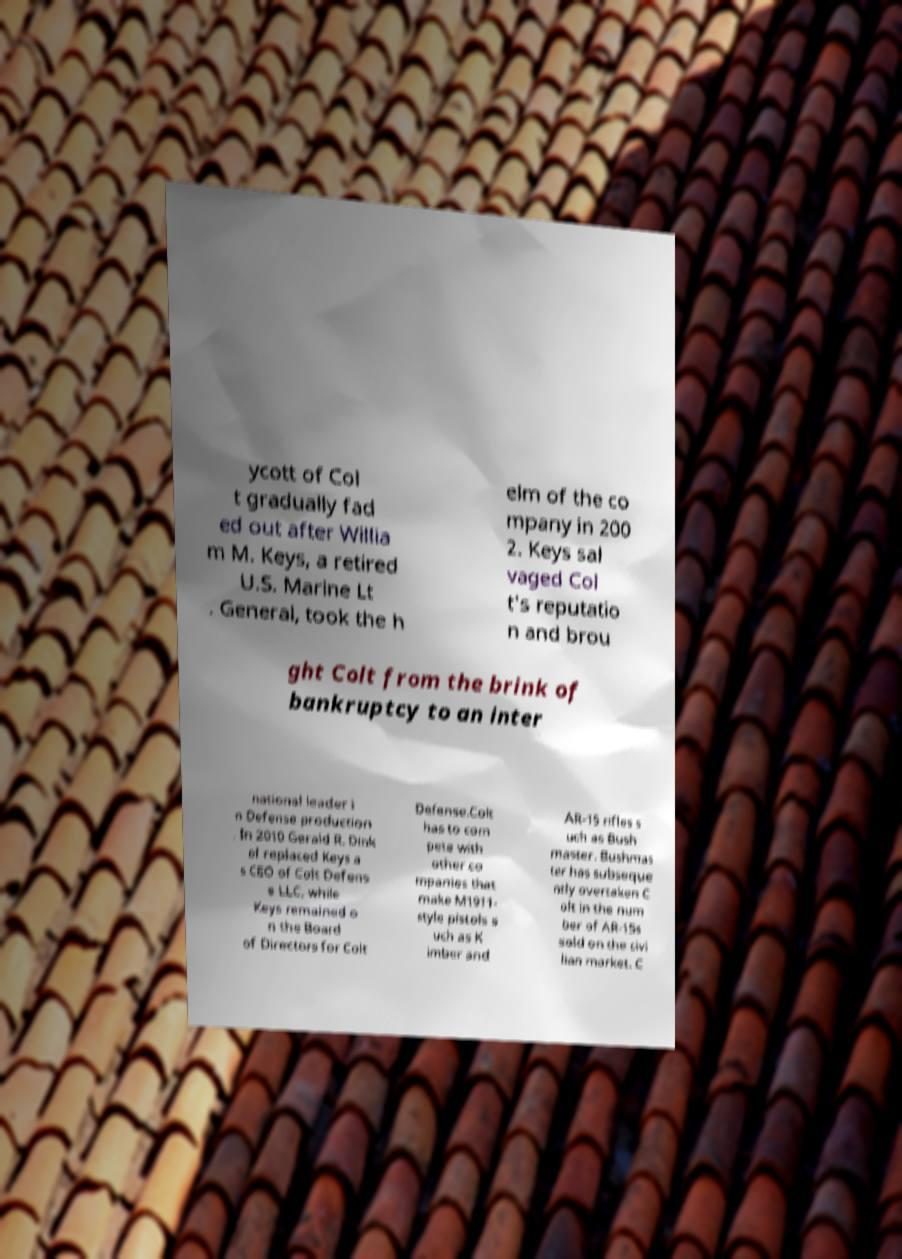Can you accurately transcribe the text from the provided image for me? ycott of Col t gradually fad ed out after Willia m M. Keys, a retired U.S. Marine Lt . General, took the h elm of the co mpany in 200 2. Keys sal vaged Col t's reputatio n and brou ght Colt from the brink of bankruptcy to an inter national leader i n Defense production . In 2010 Gerald R. Dink el replaced Keys a s CEO of Colt Defens e LLC, while Keys remained o n the Board of Directors for Colt Defense.Colt has to com pete with other co mpanies that make M1911- style pistols s uch as K imber and AR-15 rifles s uch as Bush master. Bushmas ter has subseque ntly overtaken C olt in the num ber of AR-15s sold on the civi lian market. C 